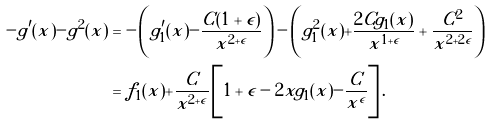<formula> <loc_0><loc_0><loc_500><loc_500>- g ^ { \prime } ( x ) - g ^ { 2 } ( x ) & = - \left ( g _ { 1 } ^ { \prime } ( x ) - \frac { C ( 1 + \epsilon ) } { x ^ { 2 + \epsilon } } \right ) - \left ( g _ { 1 } ^ { 2 } ( x ) + \frac { 2 C g _ { 1 } ( x ) } { x ^ { 1 + \epsilon } } + \frac { C ^ { 2 } } { x ^ { 2 + 2 \epsilon } } \right ) \\ & = f _ { 1 } ( x ) + \frac { C } { x ^ { 2 + \epsilon } } \left [ 1 + \epsilon - 2 x g _ { 1 } ( x ) - \frac { C } { x ^ { \epsilon } } \right ] .</formula> 